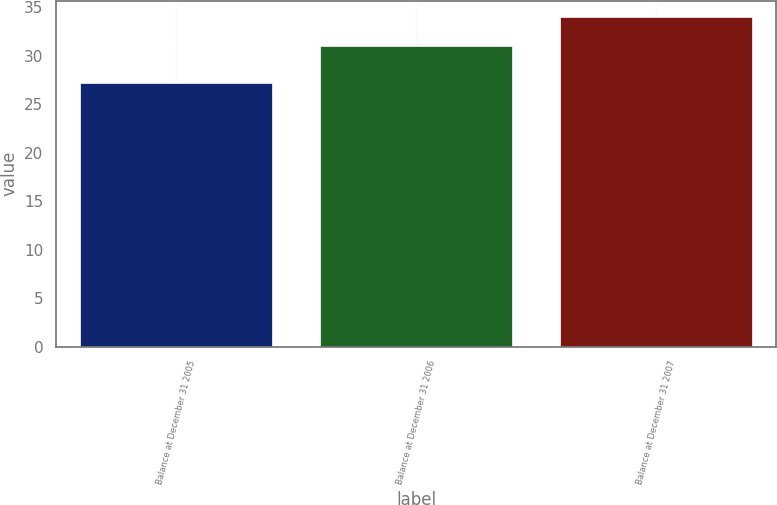<chart> <loc_0><loc_0><loc_500><loc_500><bar_chart><fcel>Balance at December 31 2005<fcel>Balance at December 31 2006<fcel>Balance at December 31 2007<nl><fcel>27.19<fcel>30.98<fcel>33.98<nl></chart> 